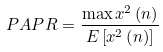Convert formula to latex. <formula><loc_0><loc_0><loc_500><loc_500>P A P R = \frac { \max { { x } ^ { 2 } } \left ( n \right ) } { E \left [ { { x } ^ { 2 } } \left ( n \right ) \right ] }</formula> 